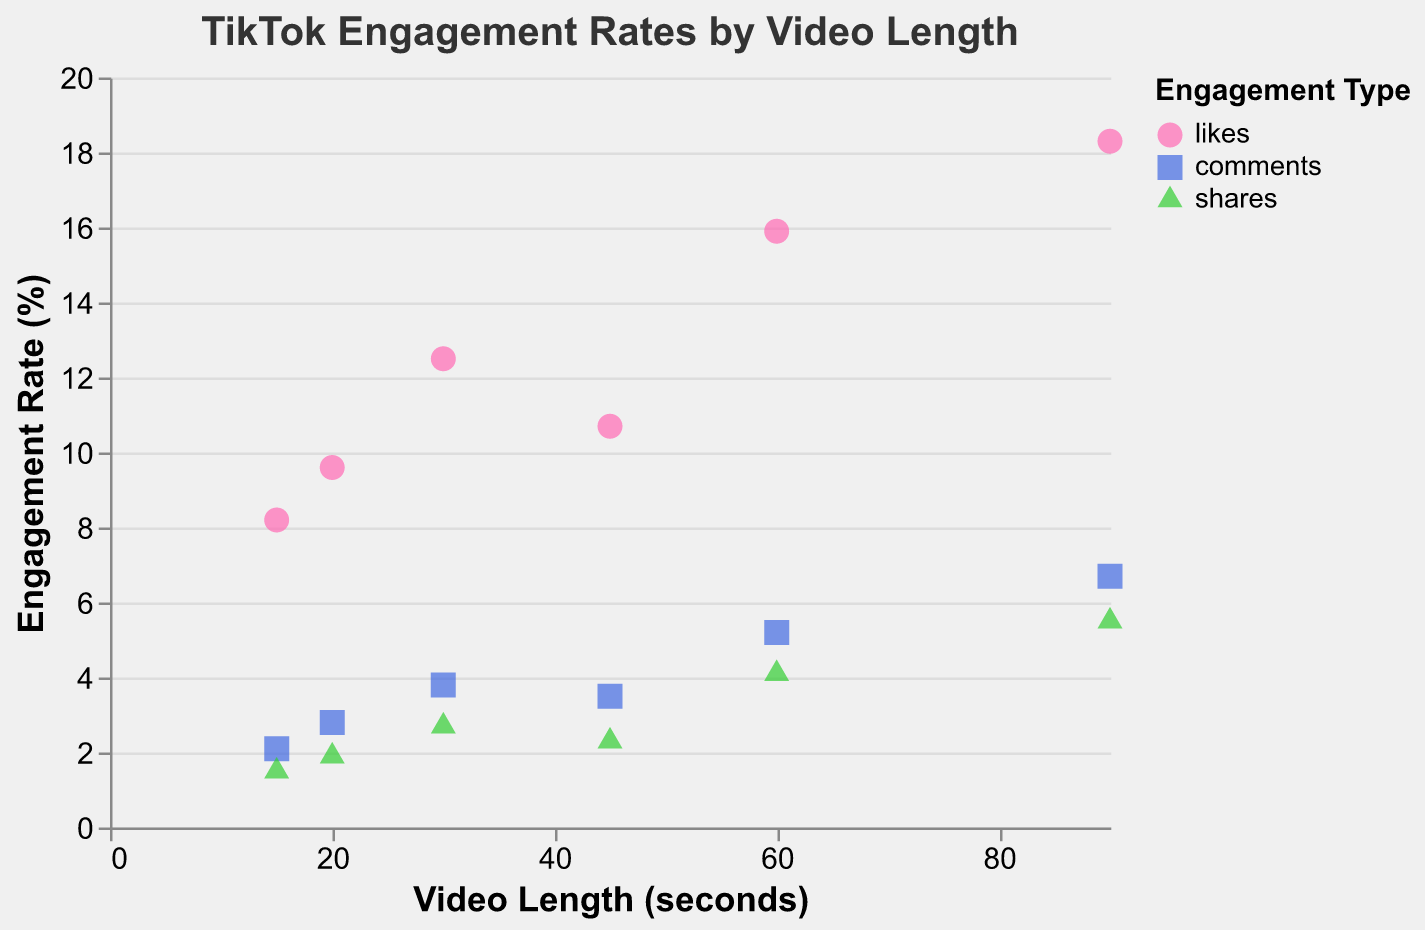What is the engagement rate of comments for 30-second videos? From the plot, locate the points representing the 30-second video length on the x-axis. Identify the color and shape representing "comments" which should be a blue square. The engagement rate is displayed on the y-axis next to this point.
Answer: 3.8 Which type of engagement has the highest rate for 60-second videos? Examine the data points for 60-second video lengths. The highest engagement rate on the y-axis is associated with the point representing "likes," indicated by the pink circle.
Answer: likes What is the engagement rate of shares for 90-second videos? Look for 90-second video lengths on the x-axis and identify the green triangle for "shares." Read the engagement rate on the y-axis.
Answer: 5.5 Compare the engagement rates of likes and comments for 45-second videos. Which one is higher? Identify the data points for 45-second videos. Find the pink circle (likes) and blue square (comments). Compare the y-axis values of these points.
Answer: likes What is the average engagement rate of likes for all video lengths? Sum the engagement rates for likes across all video lengths (8.2 + 12.5 + 15.9 + 10.7 + 9.6 + 18.3 = 75.2). There are 6 likes data points. Divide the sum by 6 (75.2 / 6).
Answer: 12.53 How does the engagement rate for comments of 15-second videos compare to that of 20-second videos? Locate the data points for 15-second and 20-second video lengths. Identify the blue squares representing comments and compare the engagement rates on the y-axis.
Answer: 2.1 vs 2.8 What is the total engagement rate for shares of videos less than 30 seconds? Identify the "shares" data for 15-second (1.5) and 20-second (1.9) videos. Sum these rates (1.5 + 1.9).
Answer: 3.4 Are there any creators with an engagement rate of shares above 4%? From the plot, identify engagement rates for shares (green triangles). Check if any are above 4%. For 60-second (4.1) and 90-second (5.5) videos, "AccraVibes" and "GhanaComedy" meet this criterion.
Answer: Yes Does the engagement rate for likes generally increase with video length? Observe the general trend of the points representing likes (pink circles) as the video length on the x-axis increases. Likes rates increase from 15s (8.2) to 60s (15.9), confirming the trend.
Answer: Yes Which video length has the lowest engagement rate for any engagement type, and which type is it? Identify the lowest point on the y-axis across all video lengths. The lowest engagement rate (1.5) is for shares at 15 seconds as shown by the green triangle.
Answer: 15 seconds, shares 